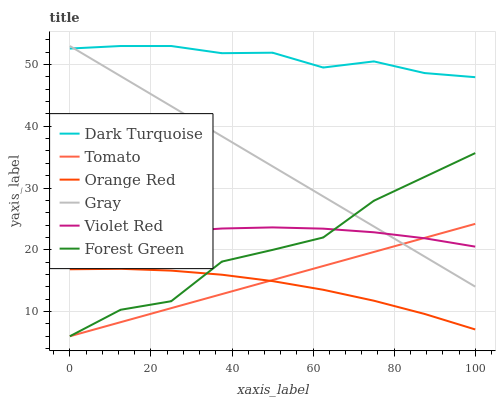Does Gray have the minimum area under the curve?
Answer yes or no. No. Does Gray have the maximum area under the curve?
Answer yes or no. No. Is Gray the smoothest?
Answer yes or no. No. Is Gray the roughest?
Answer yes or no. No. Does Gray have the lowest value?
Answer yes or no. No. Does Violet Red have the highest value?
Answer yes or no. No. Is Tomato less than Dark Turquoise?
Answer yes or no. Yes. Is Dark Turquoise greater than Forest Green?
Answer yes or no. Yes. Does Tomato intersect Dark Turquoise?
Answer yes or no. No. 